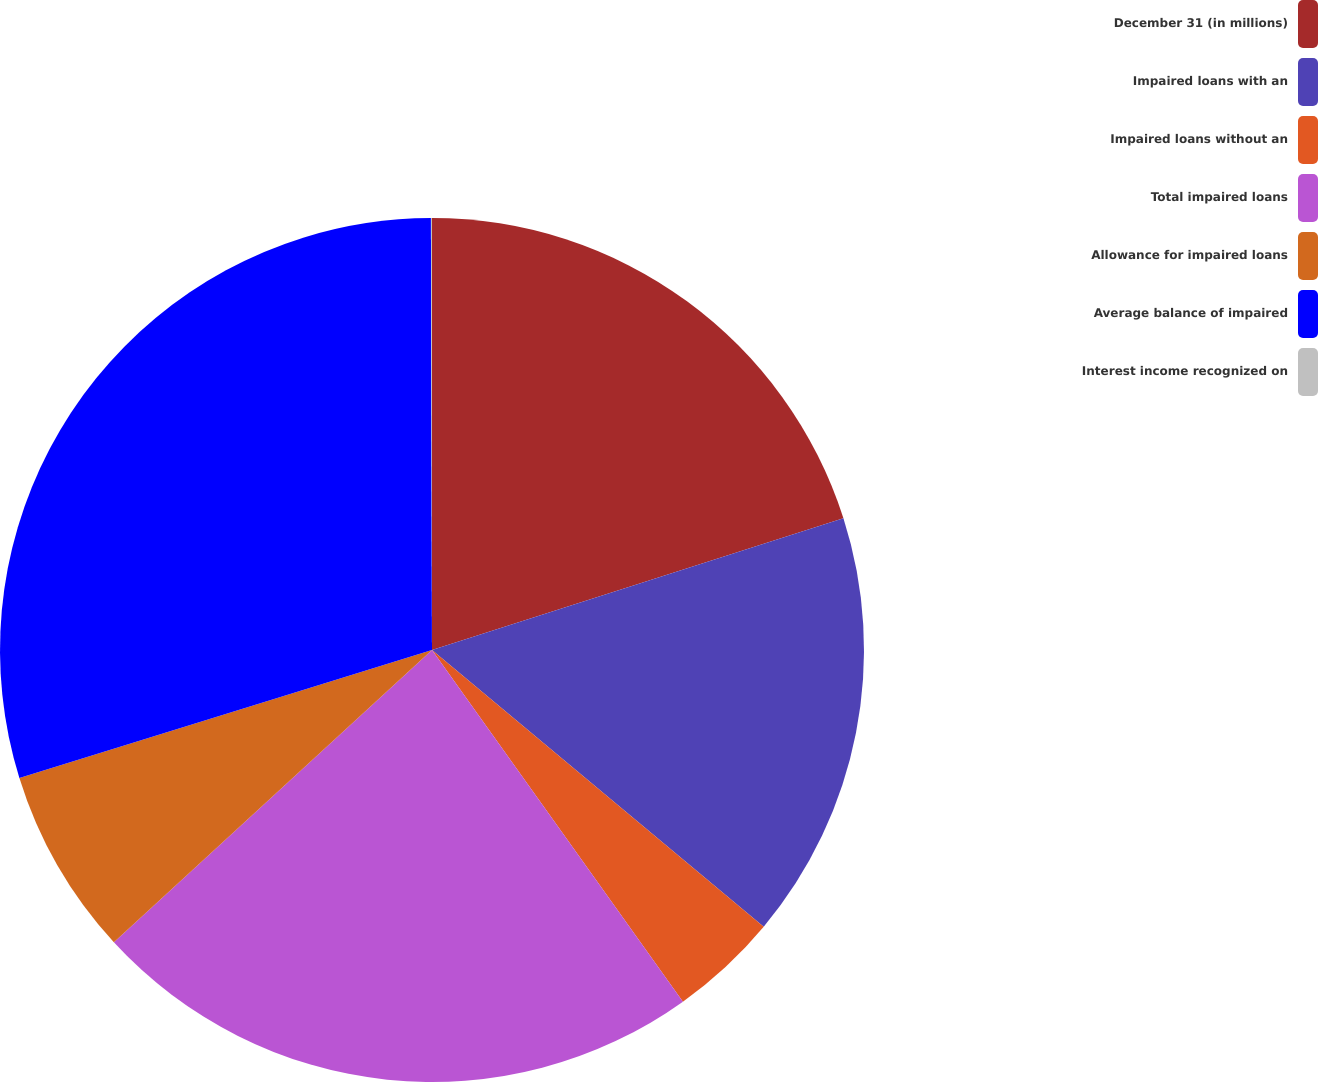Convert chart. <chart><loc_0><loc_0><loc_500><loc_500><pie_chart><fcel>December 31 (in millions)<fcel>Impaired loans with an<fcel>Impaired loans without an<fcel>Total impaired loans<fcel>Allowance for impaired loans<fcel>Average balance of impaired<fcel>Interest income recognized on<nl><fcel>20.07%<fcel>16.0%<fcel>4.07%<fcel>23.04%<fcel>7.04%<fcel>29.75%<fcel>0.04%<nl></chart> 